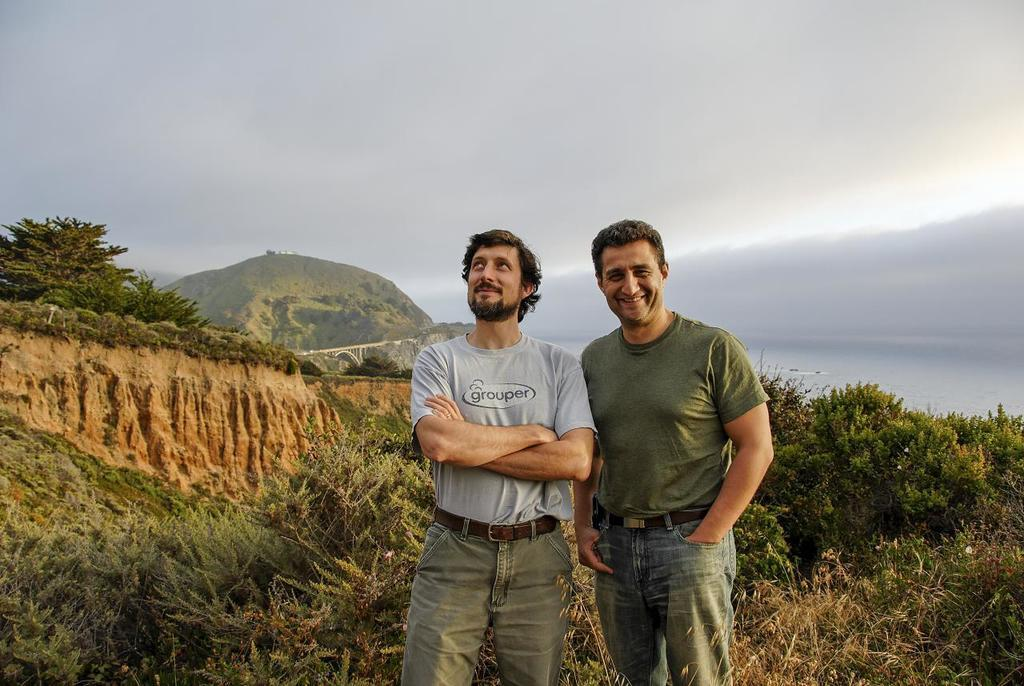How many people are in the image? There are two people standing in the image. What is the facial expression of the people in the image? The people are smiling. What type of vegetation is at the bottom of the image? There is grass at the bottom of the image. What can be seen in the background of the image? There are trees, hills, and the sky visible in the background of the image. What natural feature is visible in the image? There is water visible in the image. What is the weight of the mint plant in the image? There is no mint plant present in the image, so it is not possible to determine its weight. What type of farm animals can be seen in the image? There are no farm animals present in the image. 